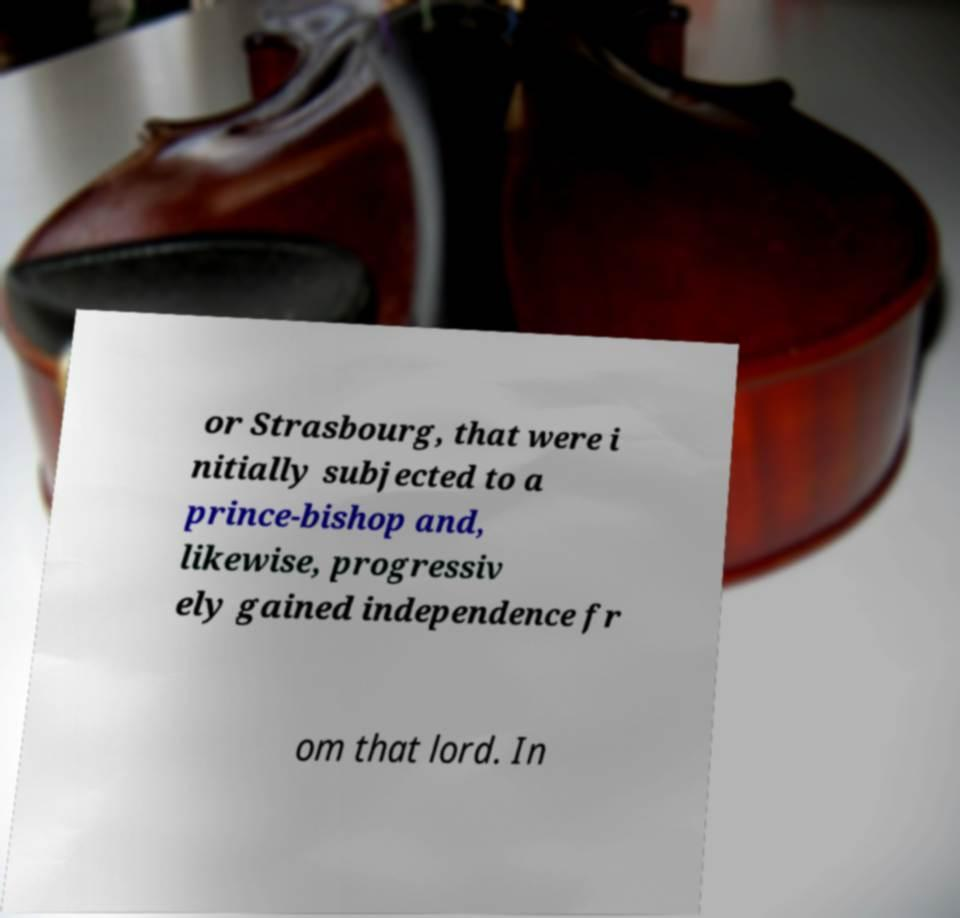Could you assist in decoding the text presented in this image and type it out clearly? or Strasbourg, that were i nitially subjected to a prince-bishop and, likewise, progressiv ely gained independence fr om that lord. In 